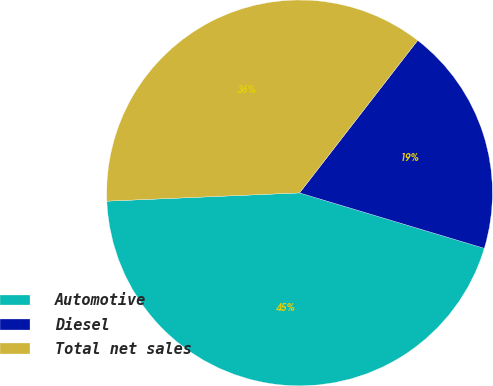Convert chart to OTSL. <chart><loc_0><loc_0><loc_500><loc_500><pie_chart><fcel>Automotive<fcel>Diesel<fcel>Total net sales<nl><fcel>44.68%<fcel>19.15%<fcel>36.17%<nl></chart> 